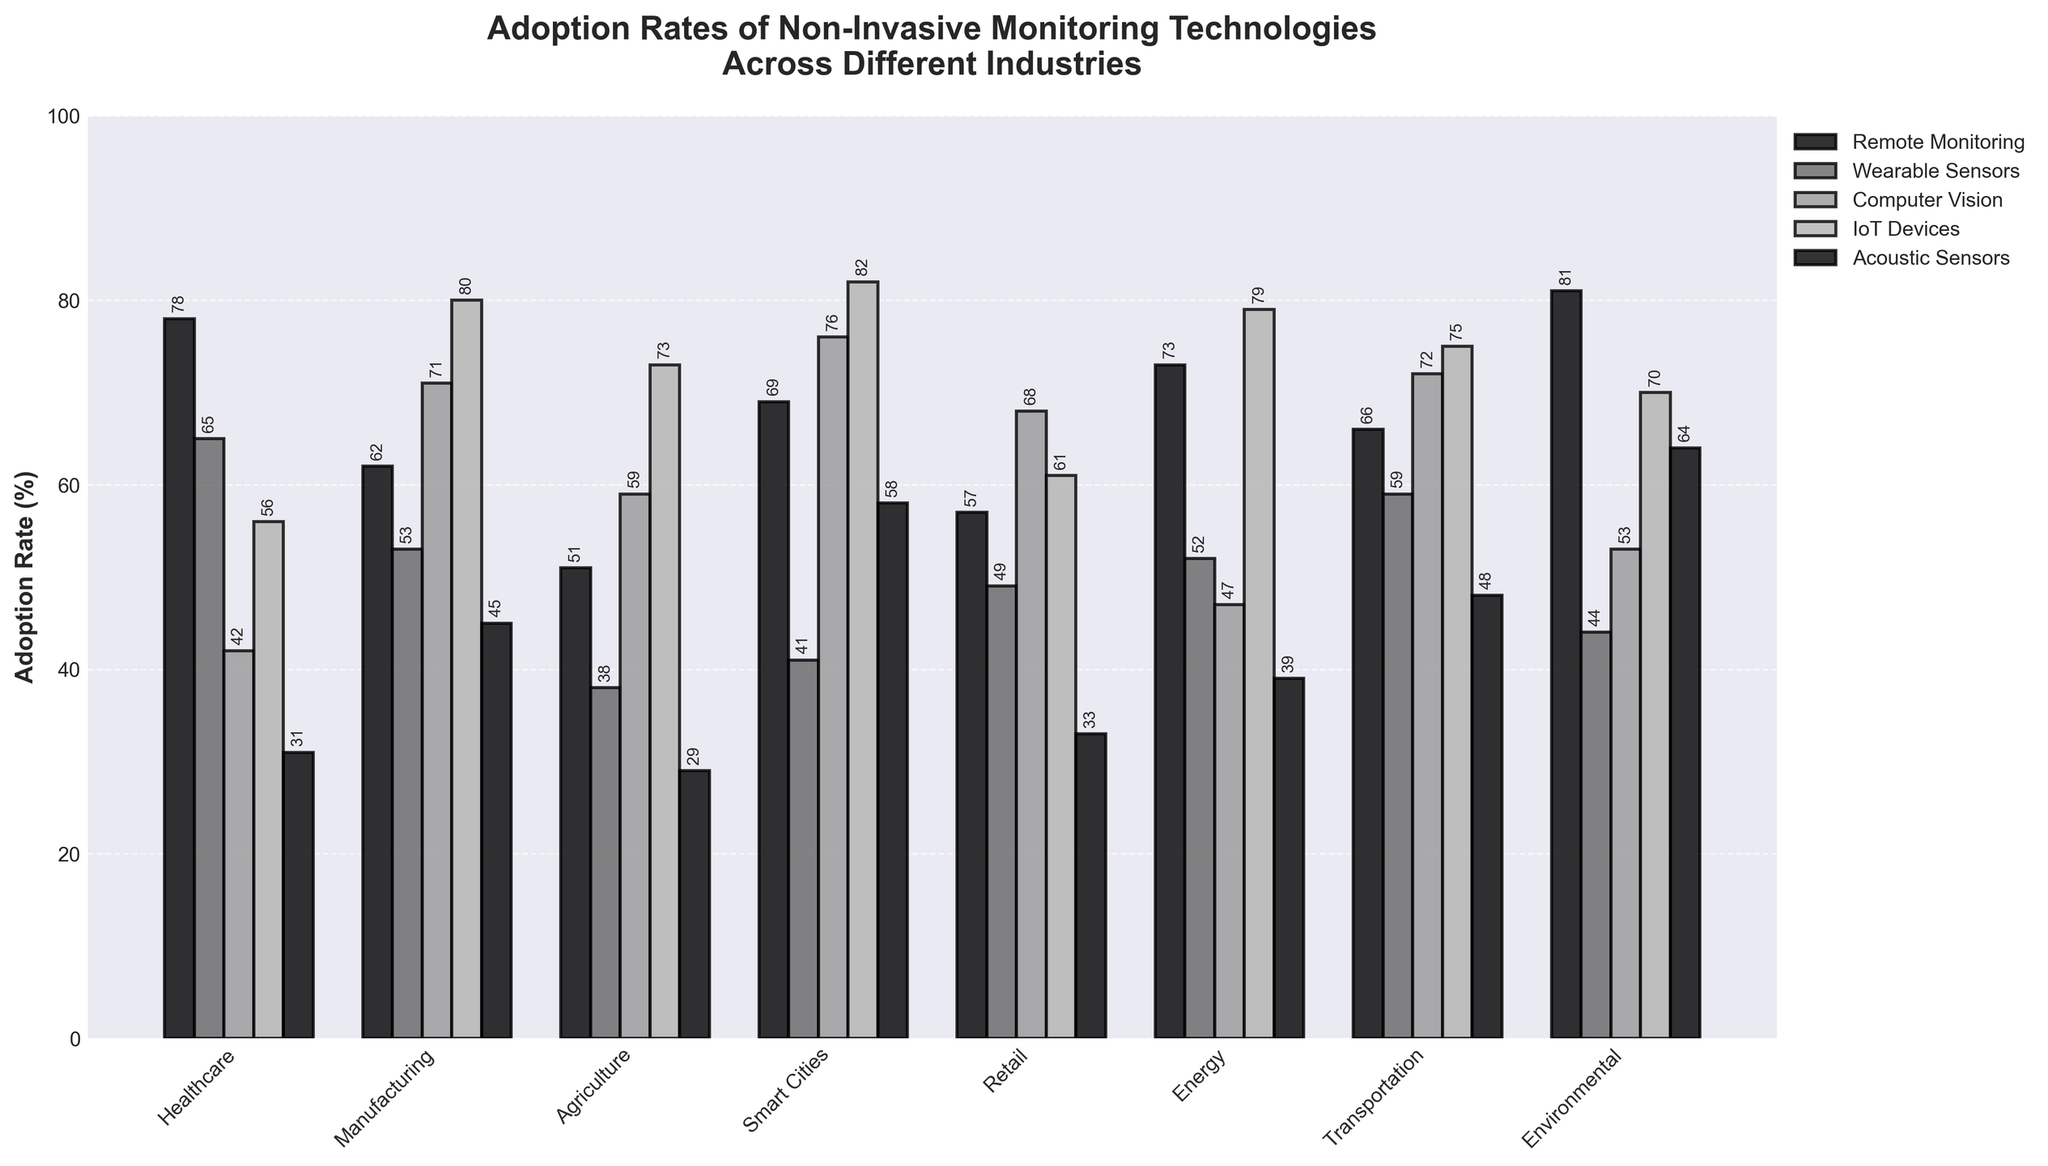Which industry has the highest adoption rate for IoT Devices? Look at the bars representing IoT Devices and identify the tallest one. The tallest bar in the IoT Devices category is for Smart Cities.
Answer: Smart Cities Compare the adoption rates of Wearable Sensors in Healthcare and Manufacturing industries. Which one is higher and by how much? Look at the heights of the bars for Wearable Sensors in both Healthcare and Manufacturing. Healthcare is 65% and Manufacturing is 53%. The difference is 65 - 53 = 12.
Answer: Healthcare by 12% What is the average adoption rate of Acoustic Sensors across all industries? Sum the adoption rates of Acoustic Sensors in all industries (31 + 45 + 29 + 58 + 33 + 39 + 48 + 64) which equals 347. There are 8 industries, so divide by 8: 347 / 8 = 43.375
Answer: 43.38% Which technology has the lowest adoption rate in the Energy industry and what is the rate? Locate the bars corresponding to each technology within the Energy industry and find the shortest one. The shortest bar represents Acoustic Sensors with an adoption rate of 39%.
Answer: Acoustic Sensors, 39% What is the total adoption rate of Computer Vision across Manufacturing and Transportation industries? Sum the adoption rates of Computer Vision in Manufacturing and Transportation. Manufacturing is 71% and Transportation is 72%. The total is 71 + 72 = 143.
Answer: 143% Compare the adoption rates of Remote Monitoring in Agriculture and Environmental industries. Which one has a higher rate and by how much? Look at the bars for Remote Monitoring in Agriculture and Environmental. Agriculture is 51% and Environmental is 81%. The difference is 81 - 51 = 30.
Answer: Environmental by 30% What is the median adoption rate of Wearable Sensors across all industries? List the adoption rates of Wearable Sensors in ascending order: 38, 41, 44, 49, 52, 53, 59, 65. The median of an even number of values is the average of the two middle values. The middle values are 49 and 52. Calculate (49 + 52) / 2 = 50.5.
Answer: 50.5% Among the industries listed, which one has the highest adoption rate for Acoustic Sensors and what is the rate? Look at the bars for Acoustic Sensors across all industries and find the tallest one. The tallest one is in the Environmental industry with a rate of 64%.
Answer: Environmental, 64% Which technology has the most consistent adoption rates across all industries? Analyze the variations in bar heights for each technology. Remote Monitoring bars appear the most consistent compared to others.
Answer: Remote Monitoring 